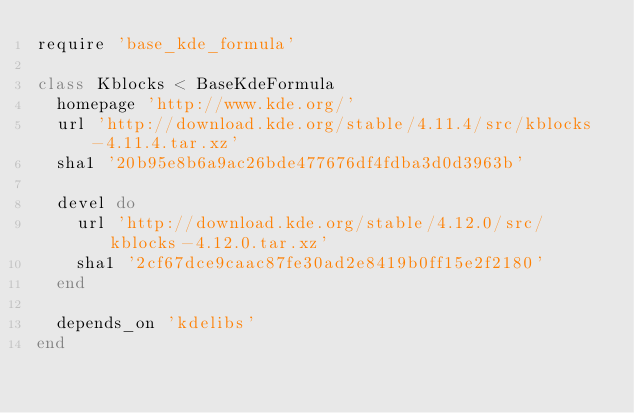Convert code to text. <code><loc_0><loc_0><loc_500><loc_500><_Ruby_>require 'base_kde_formula'

class Kblocks < BaseKdeFormula
  homepage 'http://www.kde.org/'
  url 'http://download.kde.org/stable/4.11.4/src/kblocks-4.11.4.tar.xz'
  sha1 '20b95e8b6a9ac26bde477676df4fdba3d0d3963b'

  devel do
    url 'http://download.kde.org/stable/4.12.0/src/kblocks-4.12.0.tar.xz'
    sha1 '2cf67dce9caac87fe30ad2e8419b0ff15e2f2180'
  end

  depends_on 'kdelibs'
end
</code> 